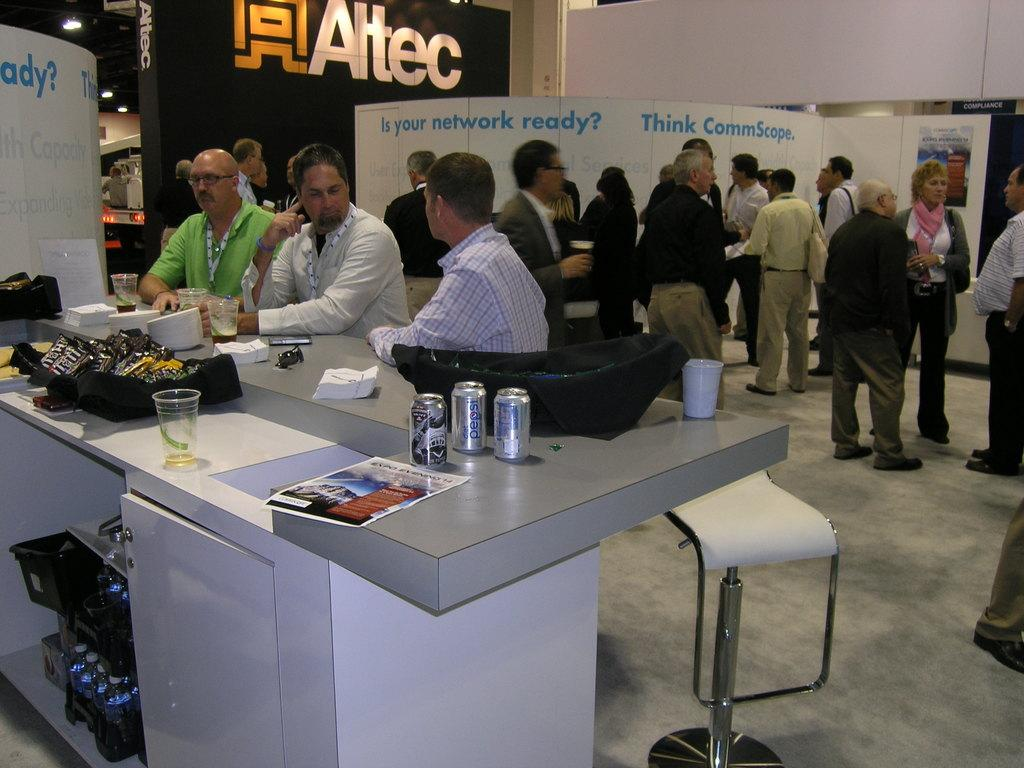How many people are present in the image? There are six people in the image, three standing and three sitting. What are the people doing in the image? The people are discussing something in the image. What is in front of the people? There is a table in front of the people. What can be seen on the table? There are different presentations on the table. What type of horn can be seen on the table in the image? There is no horn present on the table in the image. What is the total amount of debt owed by the people in the image? There is no information about debt in the image, as it focuses on people discussing and presentations on a table. 